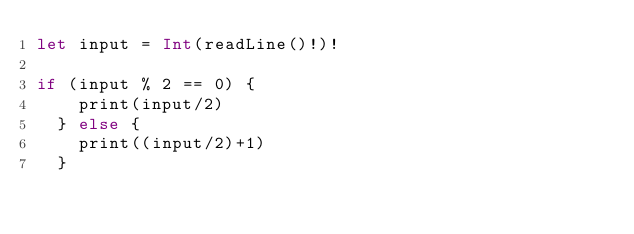<code> <loc_0><loc_0><loc_500><loc_500><_Swift_>let input = Int(readLine()!)!

if (input % 2 == 0) {
    print(input/2)
  } else {
    print((input/2)+1)
  }</code> 